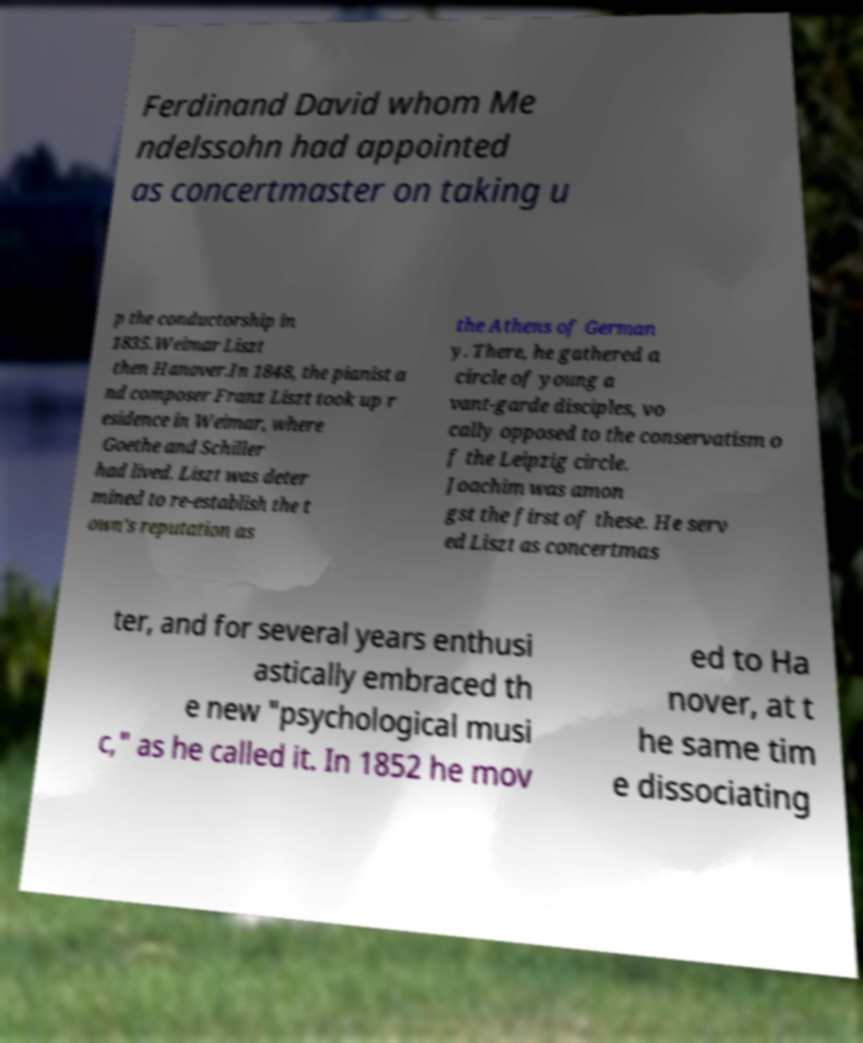Could you extract and type out the text from this image? Ferdinand David whom Me ndelssohn had appointed as concertmaster on taking u p the conductorship in 1835.Weimar Liszt then Hanover.In 1848, the pianist a nd composer Franz Liszt took up r esidence in Weimar, where Goethe and Schiller had lived. Liszt was deter mined to re-establish the t own's reputation as the Athens of German y. There, he gathered a circle of young a vant-garde disciples, vo cally opposed to the conservatism o f the Leipzig circle. Joachim was amon gst the first of these. He serv ed Liszt as concertmas ter, and for several years enthusi astically embraced th e new "psychological musi c," as he called it. In 1852 he mov ed to Ha nover, at t he same tim e dissociating 